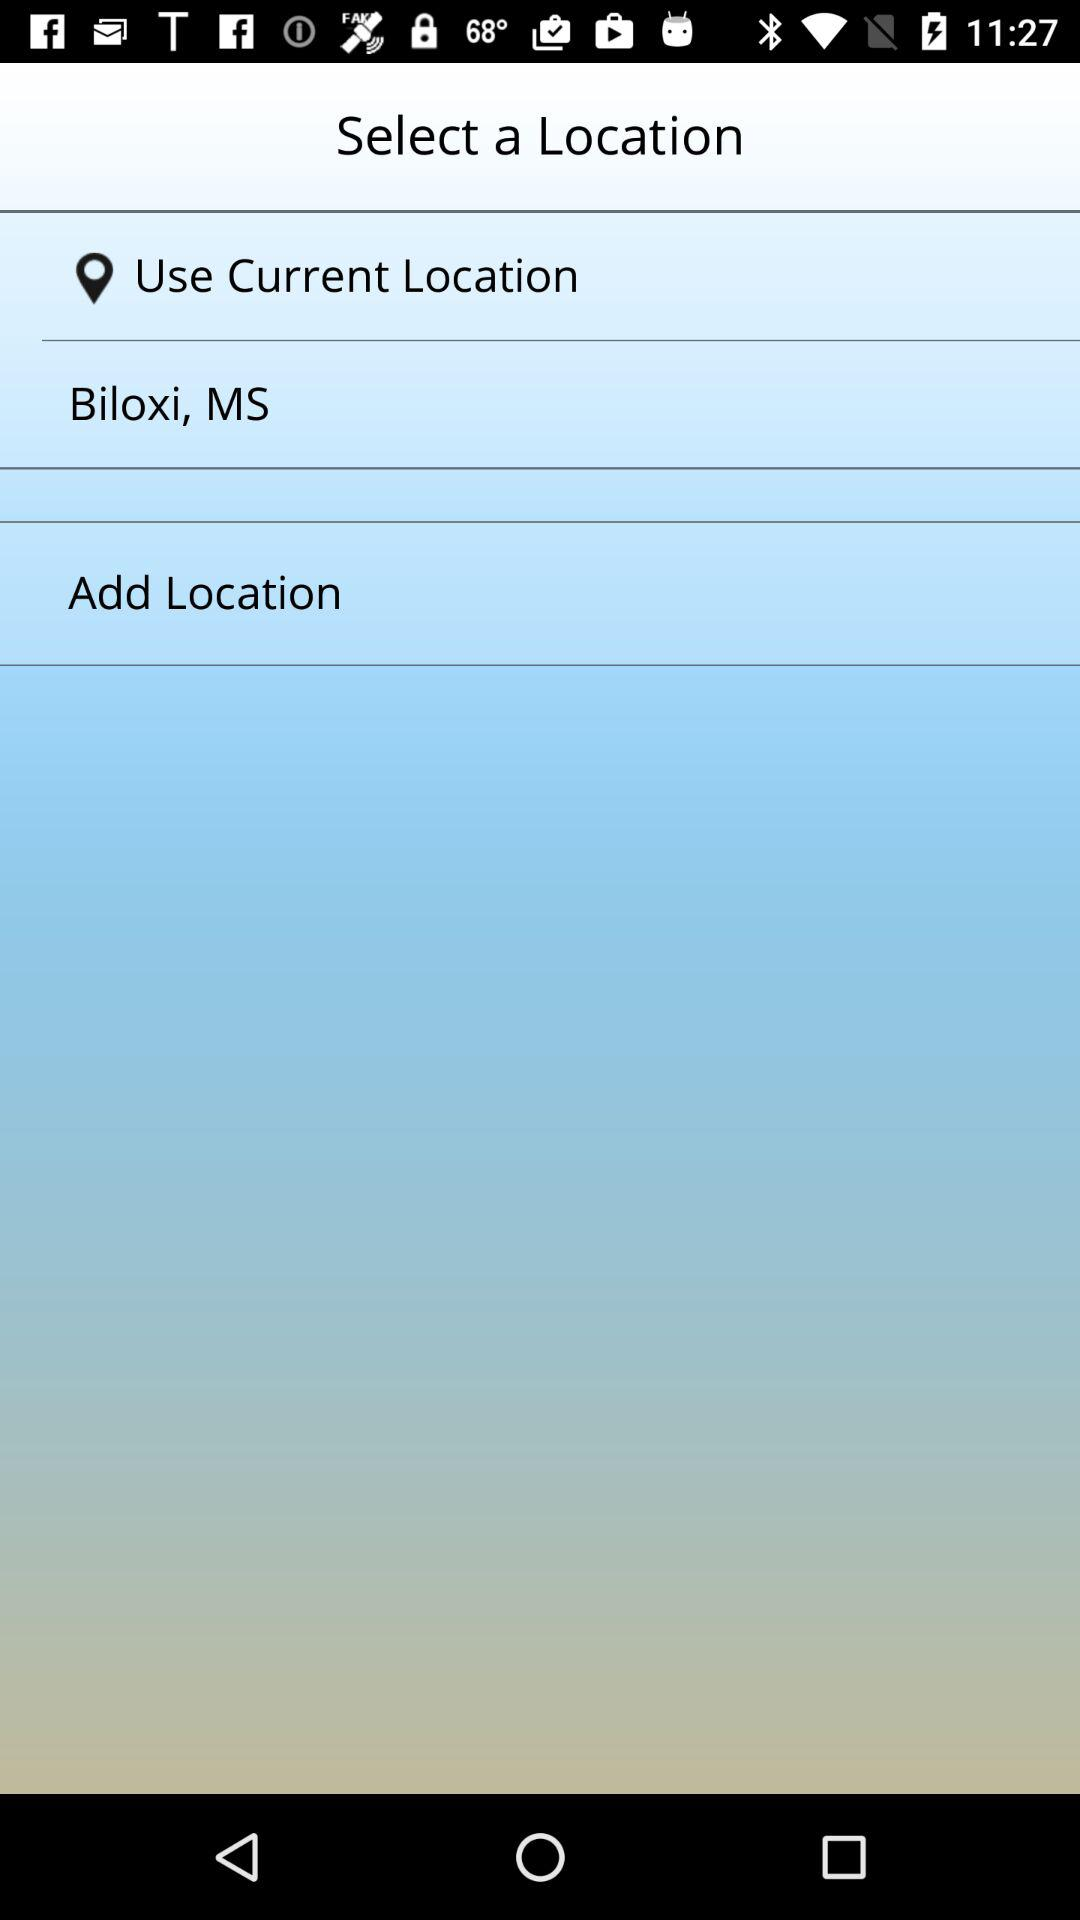What is the mentioned location? The mentioned location is Biloxi, MS. 